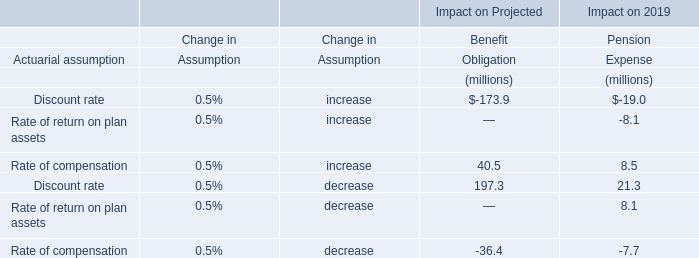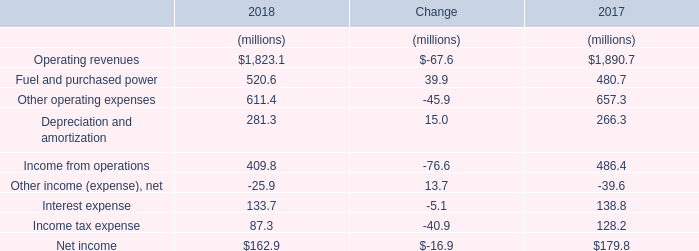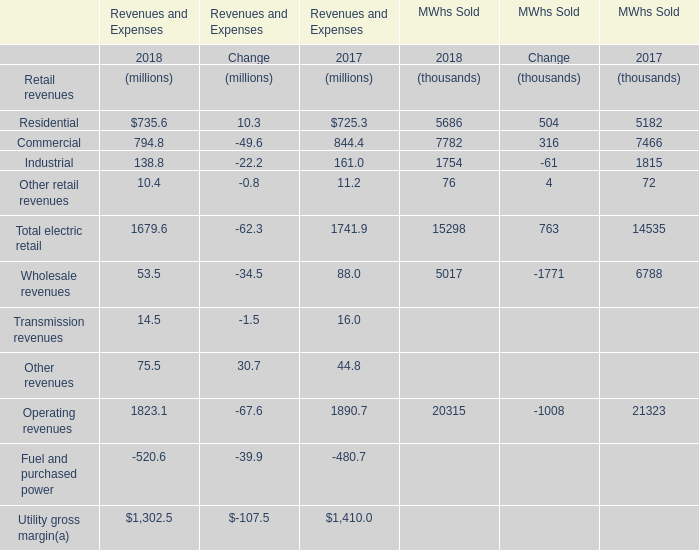What is the growing rate of Residential Retail revenues in the year with the most Other revenues? 
Computations: ((735.6 - 725.3) / 725.3)
Answer: 0.0142. 